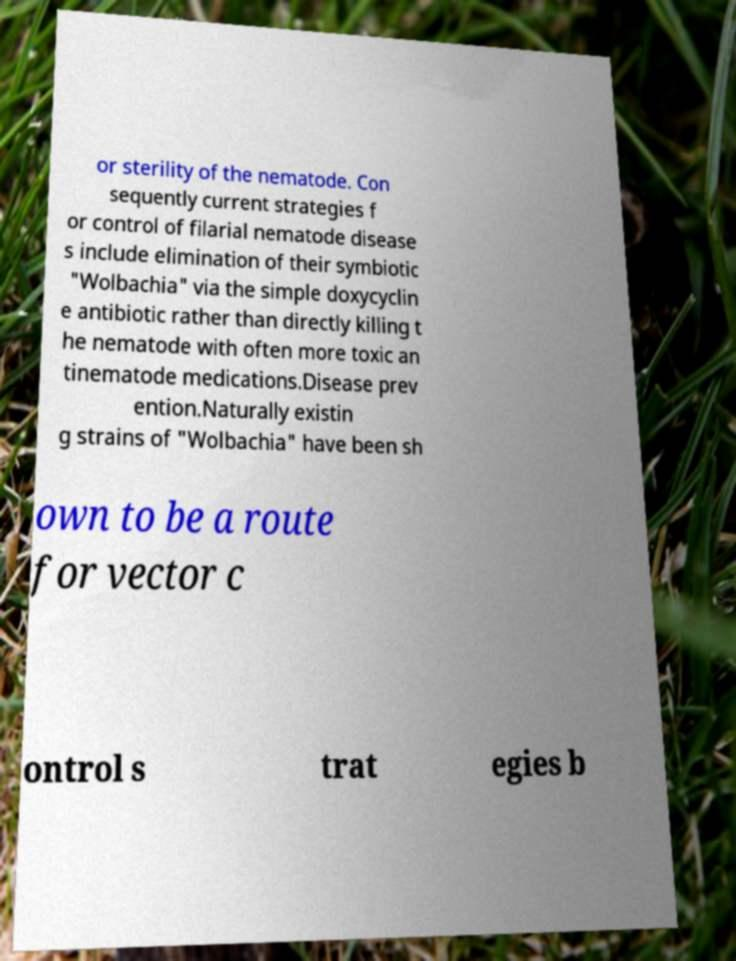For documentation purposes, I need the text within this image transcribed. Could you provide that? or sterility of the nematode. Con sequently current strategies f or control of filarial nematode disease s include elimination of their symbiotic "Wolbachia" via the simple doxycyclin e antibiotic rather than directly killing t he nematode with often more toxic an tinematode medications.Disease prev ention.Naturally existin g strains of "Wolbachia" have been sh own to be a route for vector c ontrol s trat egies b 